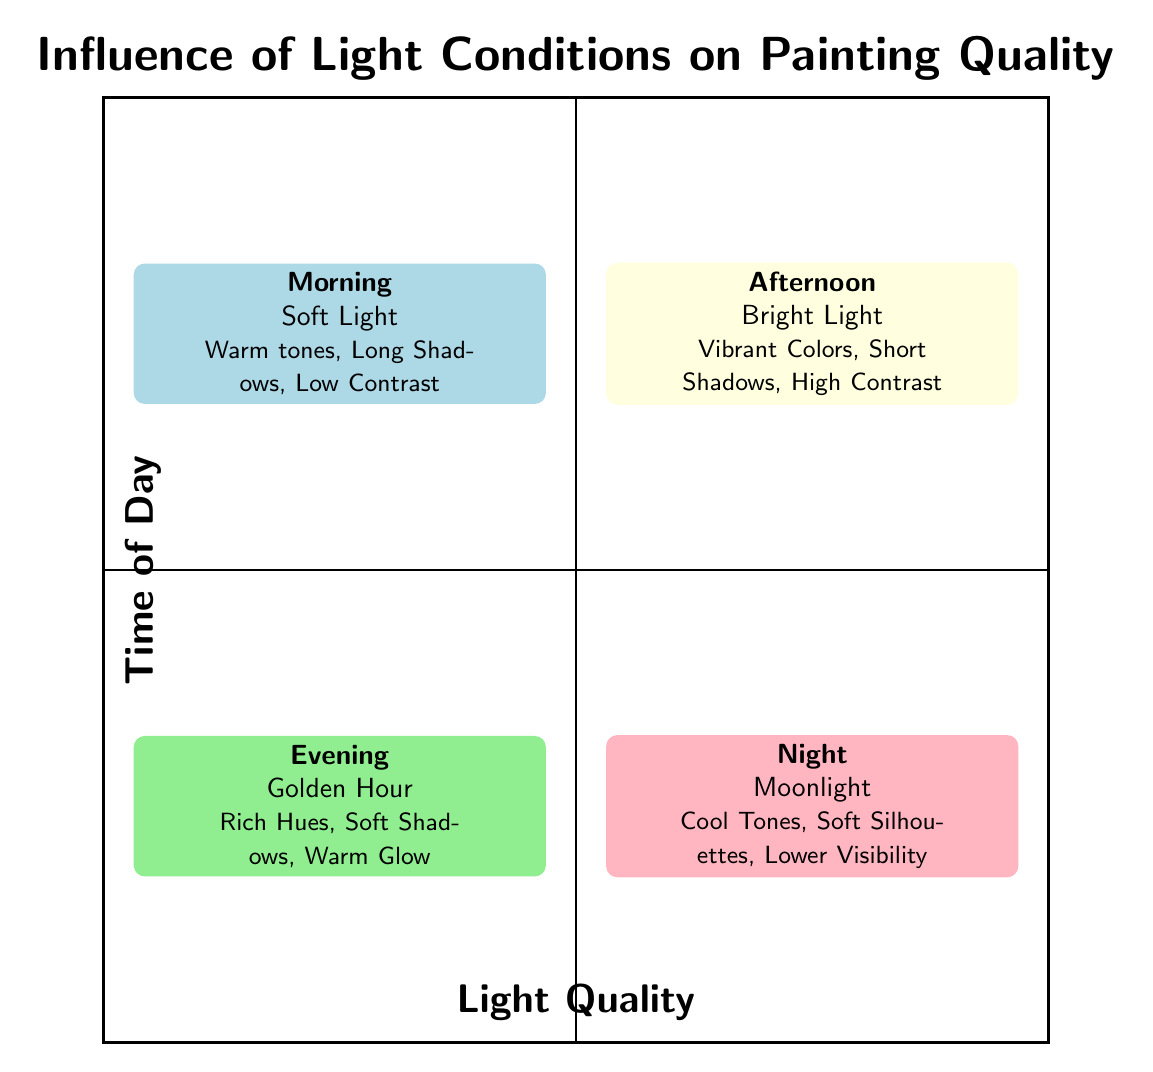What is the light quality in the Morning quadrant? In the Morning quadrant, the light quality is identified as "Soft Light" according to the label in that specific area of the diagram.
Answer: Soft Light What elements are associated with the Afternoon light condition? In the Afternoon quadrant, the associated elements are listed as "Vibrant Colors, Short Shadows, High Contrast," which are specified in the quadrant's description.
Answer: Vibrant Colors, Short Shadows, High Contrast Which quadrant has lower visibility? The Night quadrant is marked as having "Lower Visibility," indicating that it has the least visibility compared to the other quadrants in the diagram.
Answer: Night How many quadrants represent times of the day? There are four distinct quadrants in the diagram, each representing a different time of day: Morning, Afternoon, Evening, and Night.
Answer: Four Which time of day is associated with warm hues? The Evening quadrant is associated with "Rich Hues," indicating it features warm colors during that time of day.
Answer: Evening What is the commonality between the lighting conditions in the top quadrants? Both the top quadrants (Morning and Afternoon) relate to lighting conditions that are more vivid, either soft or bright, but focus on lighter forms of illumination across different times.
Answer: Light conditions What light quality do we get during the Golden Hour? The Golden Hour, described in the Evening quadrant, has a light quality that emphasizes softness and richness, noted as "Golden Hour."
Answer: Golden Hour In which quadrant are cool tones emphasized? The Night quadrant emphasizes "Cool Tones" in its lighting quality description, indicating that this is where cool color palettes are favored.
Answer: Night What time of day features long shadows? "Long Shadows" are mentioned specifically under the Morning quadrant, which indicates shadows are elongated during that time due to low light.
Answer: Morning 